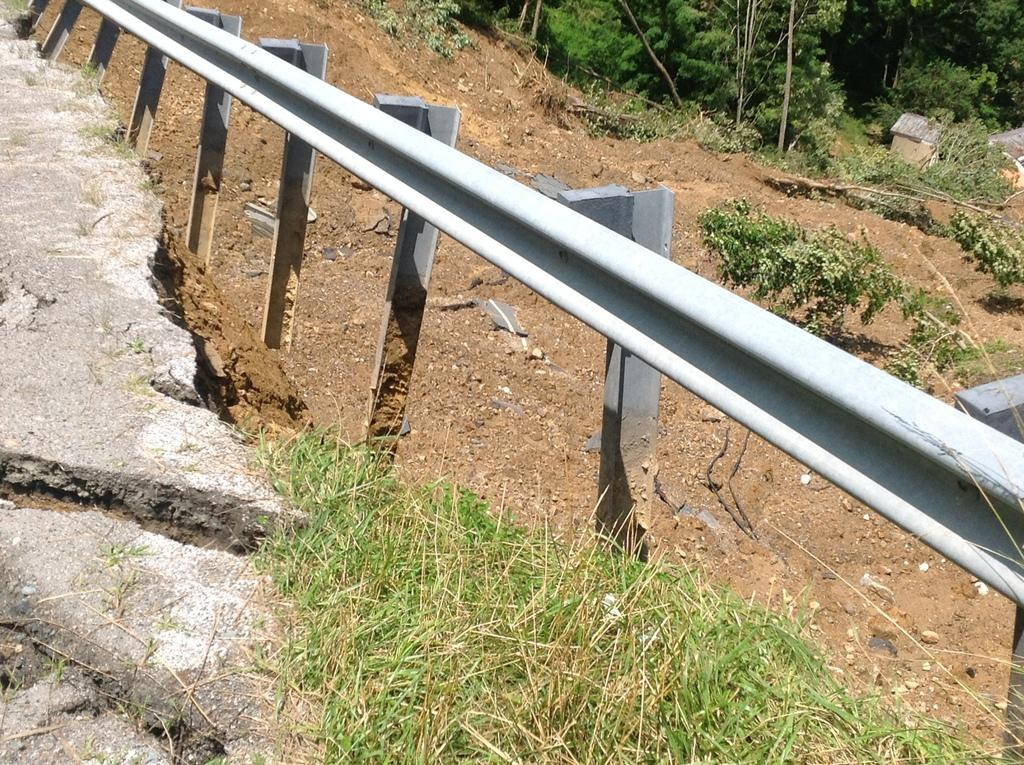What type of vegetation can be seen in the image? There is grass in the image. What is located beside the grass? There is fencing beside the grass. What is located beside the fencing? There is soil beside the fencing. What is located beside the soil? There are plants beside the soil. What can be seen in the background of the image? There are trees in the background of the image. What type of clouds can be seen in the image? There are no clouds visible in the image; it only shows grass, fencing, soil, plants, and trees. 